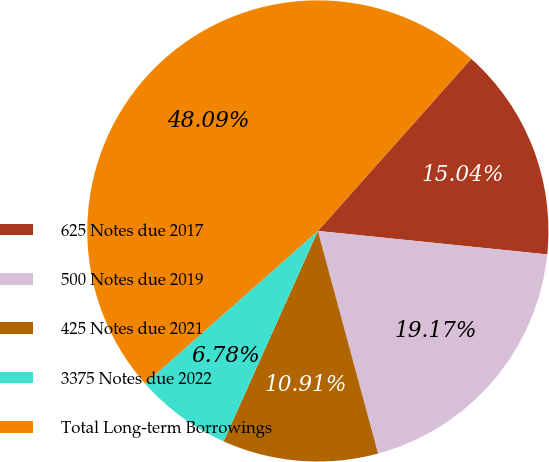<chart> <loc_0><loc_0><loc_500><loc_500><pie_chart><fcel>625 Notes due 2017<fcel>500 Notes due 2019<fcel>425 Notes due 2021<fcel>3375 Notes due 2022<fcel>Total Long-term Borrowings<nl><fcel>15.04%<fcel>19.17%<fcel>10.91%<fcel>6.78%<fcel>48.09%<nl></chart> 